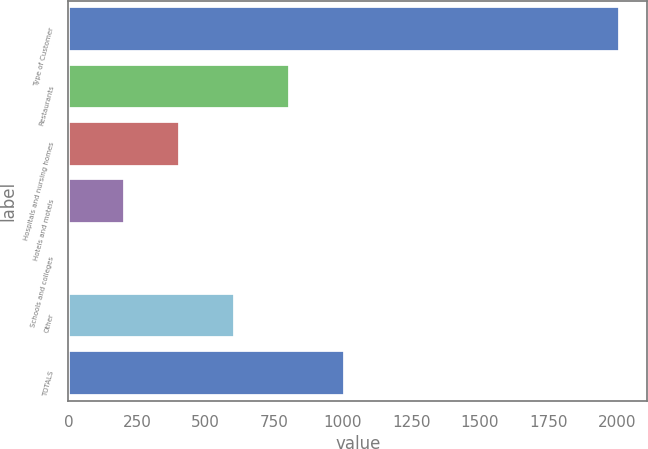<chart> <loc_0><loc_0><loc_500><loc_500><bar_chart><fcel>Type of Customer<fcel>Restaurants<fcel>Hospitals and nursing homes<fcel>Hotels and motels<fcel>Schools and colleges<fcel>Other<fcel>TOTALS<nl><fcel>2011<fcel>807.4<fcel>406.2<fcel>205.6<fcel>5<fcel>606.8<fcel>1008<nl></chart> 